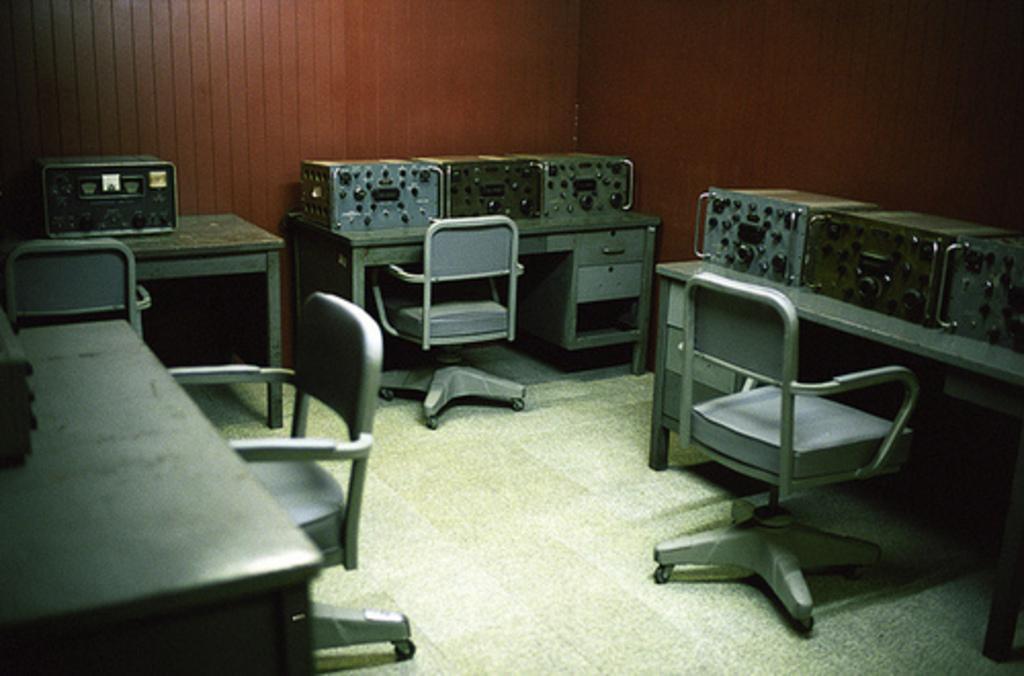Could you give a brief overview of what you see in this image? In the picture there are some equipment kept on the tables and in front of each table there is a chair. 